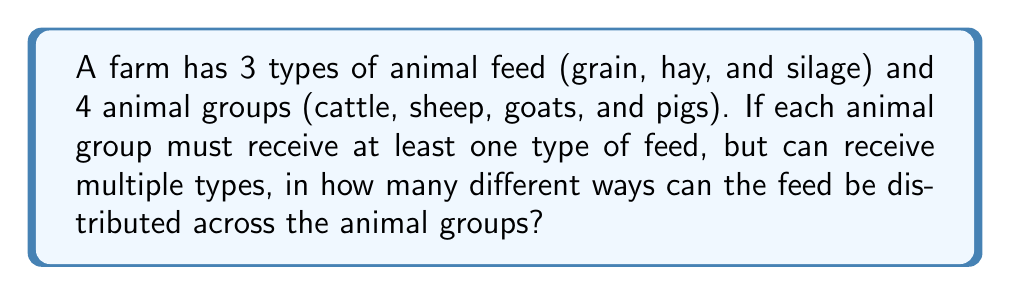What is the answer to this math problem? Let's approach this step-by-step:

1) This is a problem of distributing distinct objects (feed types) into distinct boxes (animal groups), where each box must have at least one object.

2) We can use the concept of surjective functions. We need to count the number of surjective functions from the set of feeds to the set of animal groups.

3) The formula for the number of surjective functions from a set of $m$ elements to a set of $n$ elements is:

   $$\sum_{k=0}^n (-1)^k \binom{n}{k}(n-k)^m$$

4) In our case, $m = 3$ (types of feed) and $n = 4$ (animal groups).

5) Let's substitute these values:

   $$\sum_{k=0}^4 (-1)^k \binom{4}{k}(4-k)^3$$

6) Now, let's calculate each term:
   
   For $k = 0$: $\binom{4}{0}4^3 = 1 \cdot 64 = 64$
   For $k = 1$: $-\binom{4}{1}3^3 = -4 \cdot 27 = -108$
   For $k = 2$: $\binom{4}{2}2^3 = 6 \cdot 8 = 48$
   For $k = 3$: $-\binom{4}{3}1^3 = -4 \cdot 1 = -4$
   For $k = 4$: $\binom{4}{4}0^3 = 1 \cdot 0 = 0$

7) Sum up all terms:

   $64 - 108 + 48 - 4 + 0 = 0$

8) Therefore, there are 0 ways to distribute the feed such that each animal group receives at least one type of feed.

9) This result means it's impossible to distribute 3 types of feed among 4 animal groups such that each group receives at least one type. This makes sense because with only 3 types of feed, at least one animal group will always be left without feed.
Answer: 0 